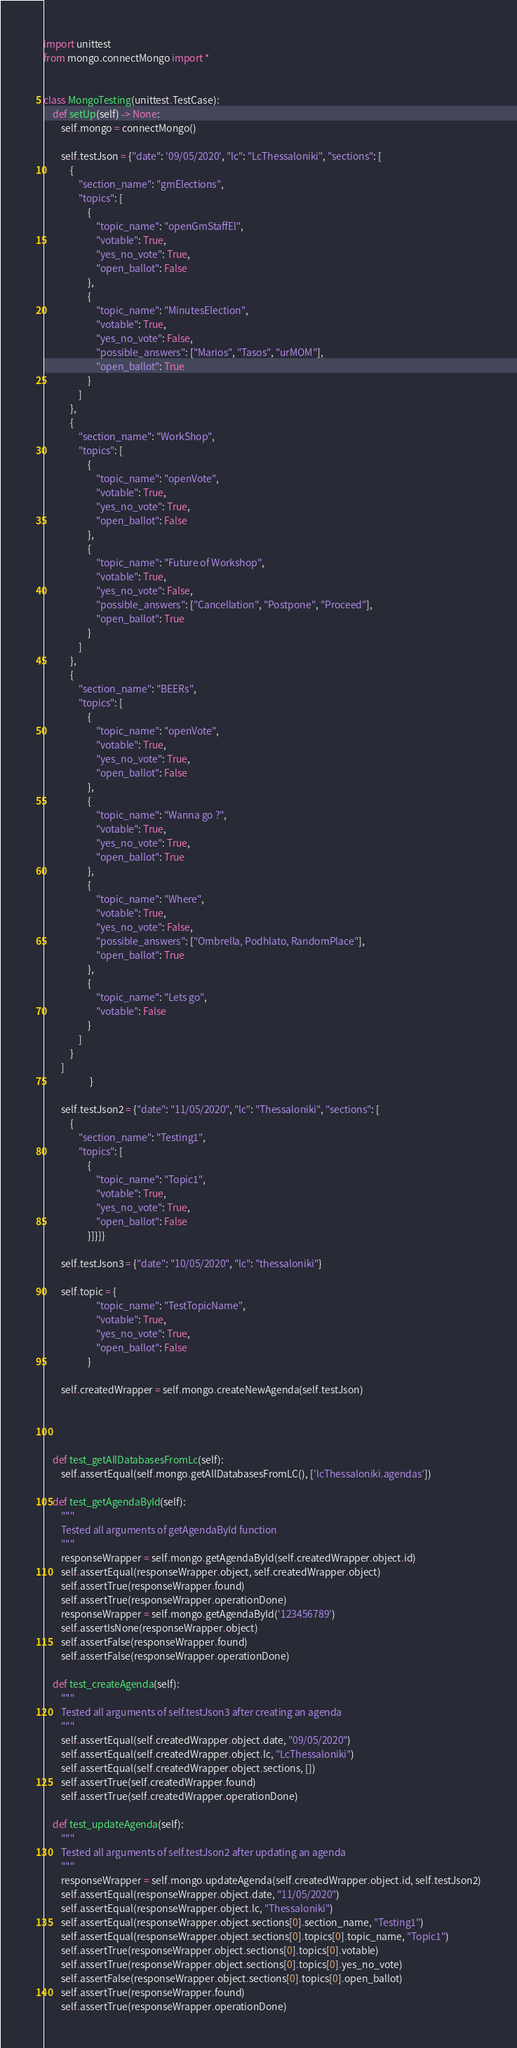Convert code to text. <code><loc_0><loc_0><loc_500><loc_500><_Python_>import unittest
from mongo.connectMongo import *


class MongoTesting(unittest.TestCase):
    def setUp(self) -> None:
        self.mongo = connectMongo()

        self.testJson = {"date": '09/05/2020', "lc": "LcThessaloniki", "sections": [
            {
                "section_name": "gmElections",
                "topics": [
                    {
                        "topic_name": "openGmStaffEl",
                        "votable": True,
                        "yes_no_vote": True,
                        "open_ballot": False
                    },
                    {
                        "topic_name": "MinutesElection",
                        "votable": True,
                        "yes_no_vote": False,
                        "possible_answers": ["Marios", "Tasos", "urMOM"],
                        "open_ballot": True
                    }
                ]
            },
            {
                "section_name": "WorkShop",
                "topics": [
                    {
                        "topic_name": "openVote",
                        "votable": True,
                        "yes_no_vote": True,
                        "open_ballot": False
                    },
                    {
                        "topic_name": "Future of Workshop",
                        "votable": True,
                        "yes_no_vote": False,
                        "possible_answers": ["Cancellation", "Postpone", "Proceed"],
                        "open_ballot": True
                    }
                ]
            },
            {
                "section_name": "BEERs",
                "topics": [
                    {
                        "topic_name": "openVote",
                        "votable": True,
                        "yes_no_vote": True,
                        "open_ballot": False
                    },
                    {
                        "topic_name": "Wanna go ?",
                        "votable": True,
                        "yes_no_vote": True,
                        "open_ballot": True
                    },
                    {
                        "topic_name": "Where",
                        "votable": True,
                        "yes_no_vote": False,
                        "possible_answers": ["Ombrella, Podhlato, RandomPlace"],
                        "open_ballot": True
                    },
                    {
                        "topic_name": "Lets go",
                        "votable": False
                    }
                ]
            }
        ]
                     }

        self.testJson2 = {"date": "11/05/2020", "lc": "Thessaloniki", "sections": [
            {
                "section_name": "Testing1",
                "topics": [
                    {
                        "topic_name": "Topic1",
                        "votable": True,
                        "yes_no_vote": True,
                        "open_ballot": False
                    }]}]}

        self.testJson3 = {"date": "10/05/2020", "lc": "thessaloniki"}

        self.topic = {
                        "topic_name": "TestTopicName",
                        "votable": True,
                        "yes_no_vote": True,
                        "open_ballot": False
                    }

        self.createdWrapper = self.mongo.createNewAgenda(self.testJson)




    def test_getAllDatabasesFromLc(self):
        self.assertEqual(self.mongo.getAllDatabasesFromLC(), ['lcThessaloniki.agendas'])

    def test_getAgendaById(self):
        """
        Tested all arguments of getAgendaById function
        """
        responseWrapper = self.mongo.getAgendaById(self.createdWrapper.object.id)
        self.assertEqual(responseWrapper.object, self.createdWrapper.object)
        self.assertTrue(responseWrapper.found)
        self.assertTrue(responseWrapper.operationDone)
        responseWrapper = self.mongo.getAgendaById('123456789')
        self.assertIsNone(responseWrapper.object)
        self.assertFalse(responseWrapper.found)
        self.assertFalse(responseWrapper.operationDone)

    def test_createAgenda(self):
        """
        Tested all arguments of self.testJson3 after creating an agenda
        """
        self.assertEqual(self.createdWrapper.object.date, "09/05/2020")
        self.assertEqual(self.createdWrapper.object.lc, "LcThessaloniki")
        self.assertEqual(self.createdWrapper.object.sections, [])
        self.assertTrue(self.createdWrapper.found)
        self.assertTrue(self.createdWrapper.operationDone)

    def test_updateAgenda(self):
        """
        Tested all arguments of self.testJson2 after updating an agenda
        """
        responseWrapper = self.mongo.updateAgenda(self.createdWrapper.object.id, self.testJson2)
        self.assertEqual(responseWrapper.object.date, "11/05/2020")
        self.assertEqual(responseWrapper.object.lc, "Thessaloniki")
        self.assertEqual(responseWrapper.object.sections[0].section_name, "Testing1")
        self.assertEqual(responseWrapper.object.sections[0].topics[0].topic_name, "Topic1")
        self.assertTrue(responseWrapper.object.sections[0].topics[0].votable)
        self.assertTrue(responseWrapper.object.sections[0].topics[0].yes_no_vote)
        self.assertFalse(responseWrapper.object.sections[0].topics[0].open_ballot)
        self.assertTrue(responseWrapper.found)
        self.assertTrue(responseWrapper.operationDone)
</code> 